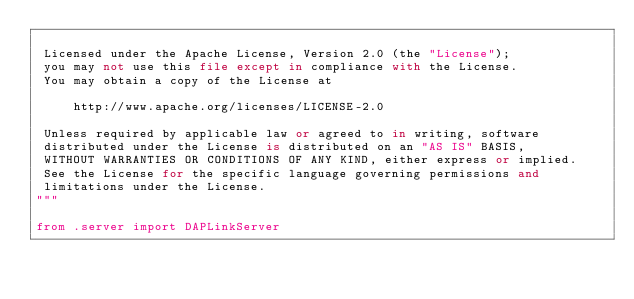<code> <loc_0><loc_0><loc_500><loc_500><_Python_>
 Licensed under the Apache License, Version 2.0 (the "License");
 you may not use this file except in compliance with the License.
 You may obtain a copy of the License at

     http://www.apache.org/licenses/LICENSE-2.0

 Unless required by applicable law or agreed to in writing, software
 distributed under the License is distributed on an "AS IS" BASIS,
 WITHOUT WARRANTIES OR CONDITIONS OF ANY KIND, either express or implied.
 See the License for the specific language governing permissions and
 limitations under the License.
"""

from .server import DAPLinkServer

</code> 